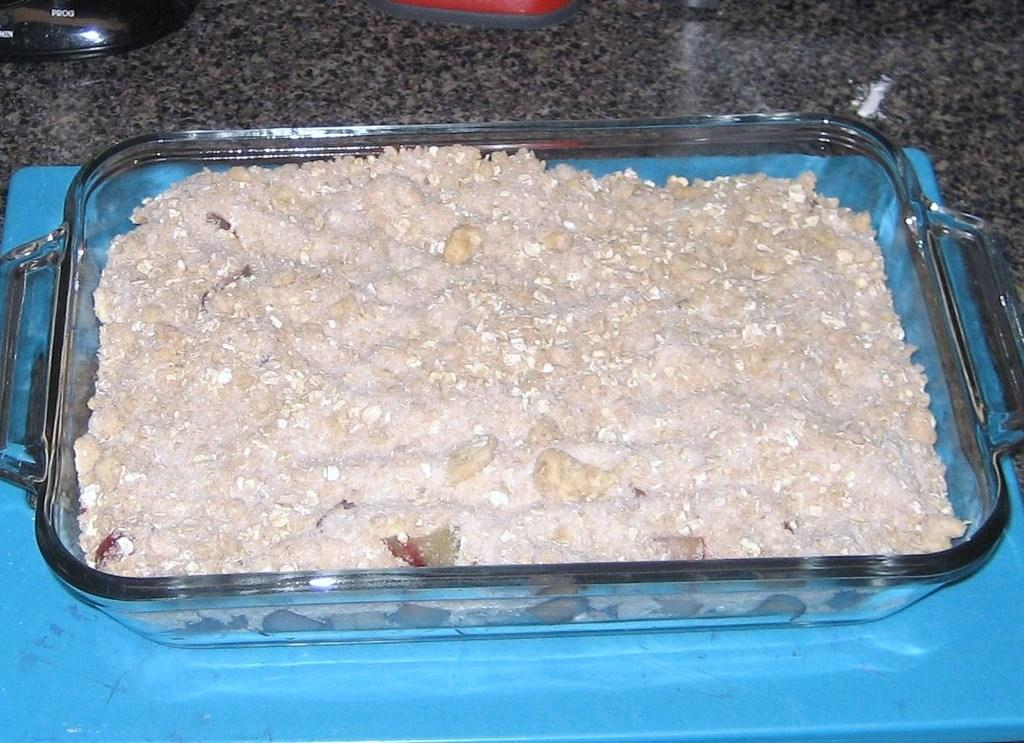What is on the tray in the image? There are food items on a tray in the image. What color is the surface the tray is on? The tray is on a blue colored surface. What else can be seen on the kitchen slab in the image? There are other objects on a kitchen slab in the image. What invention is being demonstrated in the image? There is no invention being demonstrated in the image; it simply shows food items on a tray and other objects on a kitchen slab. Can you see any wings in the image? There are no wings visible in the image. 